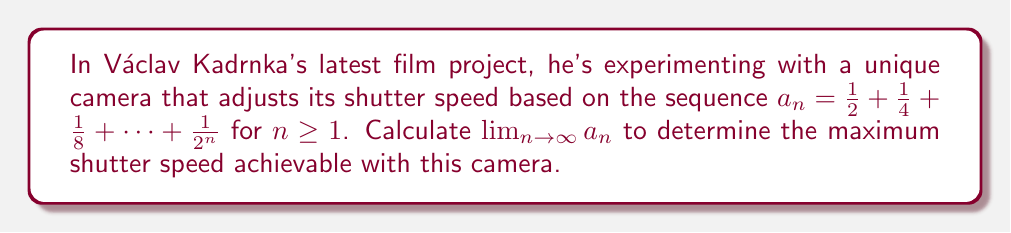Can you solve this math problem? To solve this problem, let's approach it step-by-step:

1) First, we recognize that this is a geometric series with first term $a = \frac{1}{2}$ and common ratio $r = \frac{1}{2}$.

2) The sum of a geometric series with $n$ terms is given by the formula:

   $$S_n = \frac{a(1-r^n)}{1-r}$$

   where $a$ is the first term and $r$ is the common ratio.

3) In our case, $a = \frac{1}{2}$ and $r = \frac{1}{2}$. Substituting these values:

   $$a_n = \frac{\frac{1}{2}(1-(\frac{1}{2})^n)}{1-\frac{1}{2}}$$

4) Simplifying:

   $$a_n = \frac{\frac{1}{2}(1-\frac{1}{2^n})}{\frac{1}{2}} = 1 - \frac{1}{2^n}$$

5) Now, to find the limit as $n$ approaches infinity:

   $$\lim_{n \to \infty} a_n = \lim_{n \to \infty} (1 - \frac{1}{2^n})$$

6) As $n$ approaches infinity, $\frac{1}{2^n}$ approaches 0, so:

   $$\lim_{n \to \infty} a_n = 1 - 0 = 1$$

Therefore, the sequence converges to 1.
Answer: The limit of the sequence is 1, meaning the maximum shutter speed achievable with this camera is 1 second. 